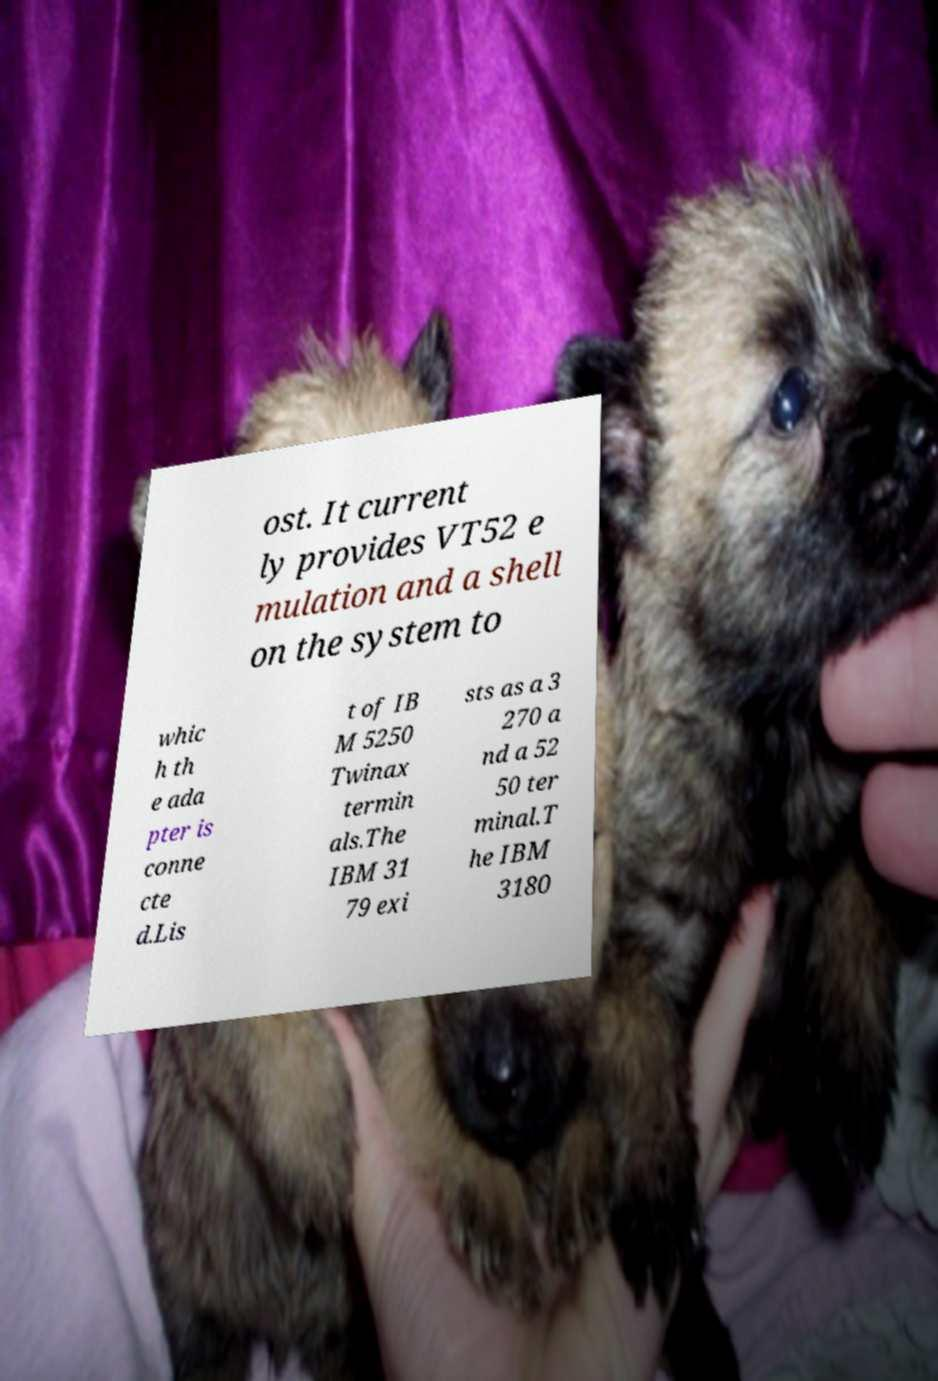Can you read and provide the text displayed in the image?This photo seems to have some interesting text. Can you extract and type it out for me? ost. It current ly provides VT52 e mulation and a shell on the system to whic h th e ada pter is conne cte d.Lis t of IB M 5250 Twinax termin als.The IBM 31 79 exi sts as a 3 270 a nd a 52 50 ter minal.T he IBM 3180 